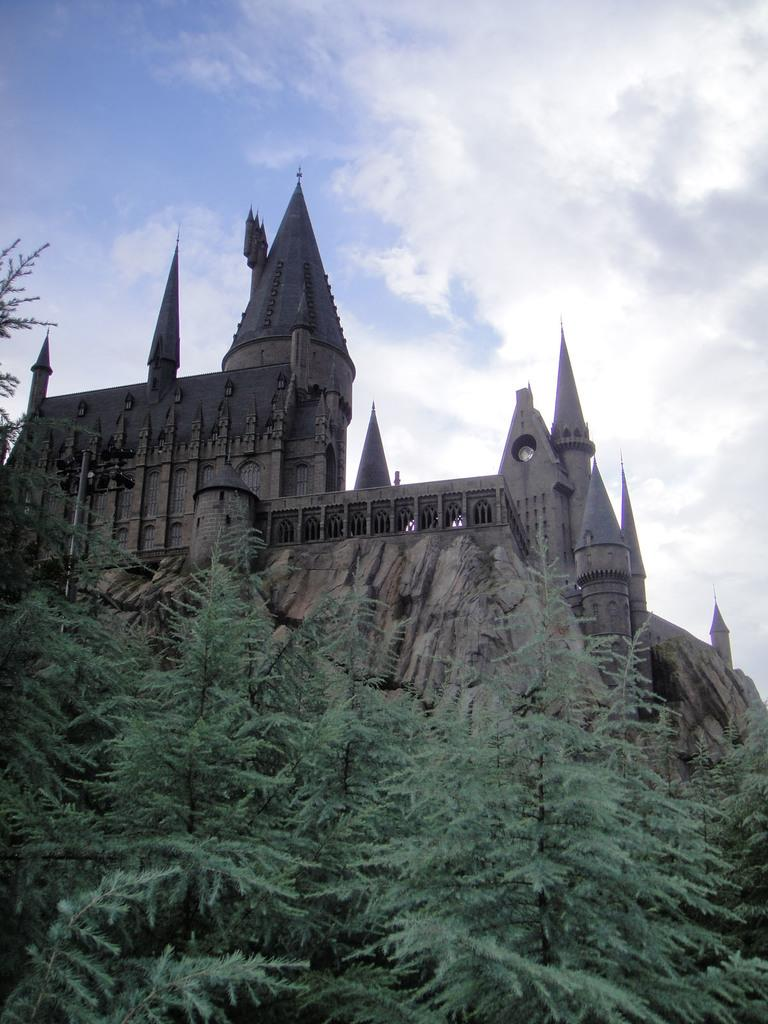What is the main structure visible in the image? There is a building in the image. What type of natural elements are present near the building? There are many trees near the building. What can be seen in the background of the image? There are clouds and a blue sky in the background of the image. Is there a river flowing near the building in the image? There is no river visible in the image. 